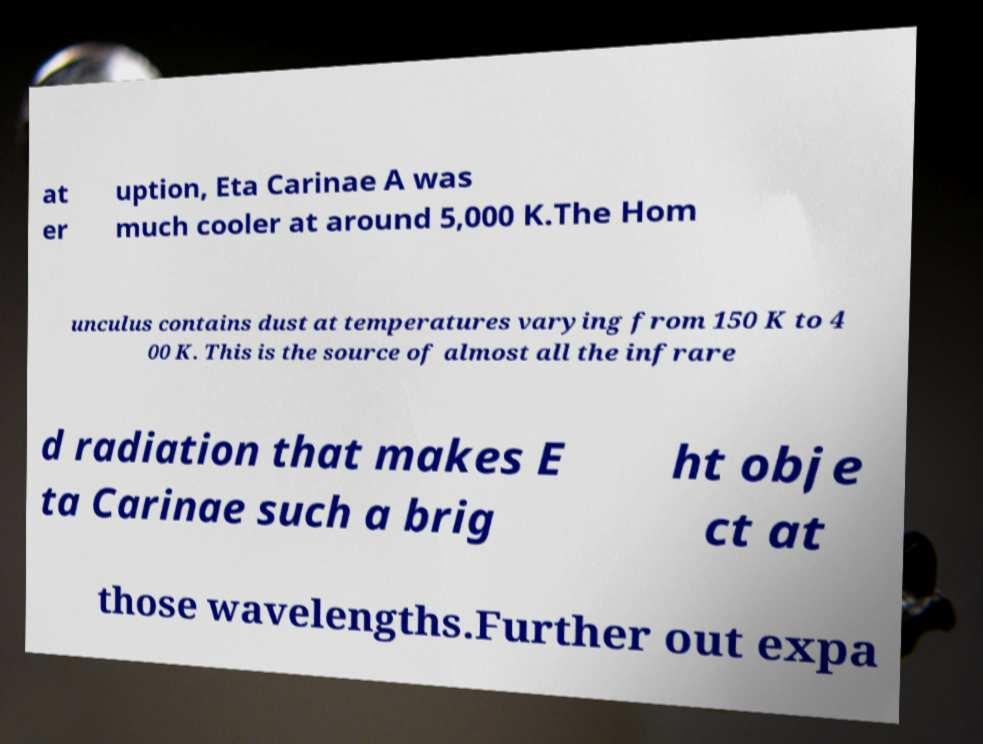There's text embedded in this image that I need extracted. Can you transcribe it verbatim? at er uption, Eta Carinae A was much cooler at around 5,000 K.The Hom unculus contains dust at temperatures varying from 150 K to 4 00 K. This is the source of almost all the infrare d radiation that makes E ta Carinae such a brig ht obje ct at those wavelengths.Further out expa 